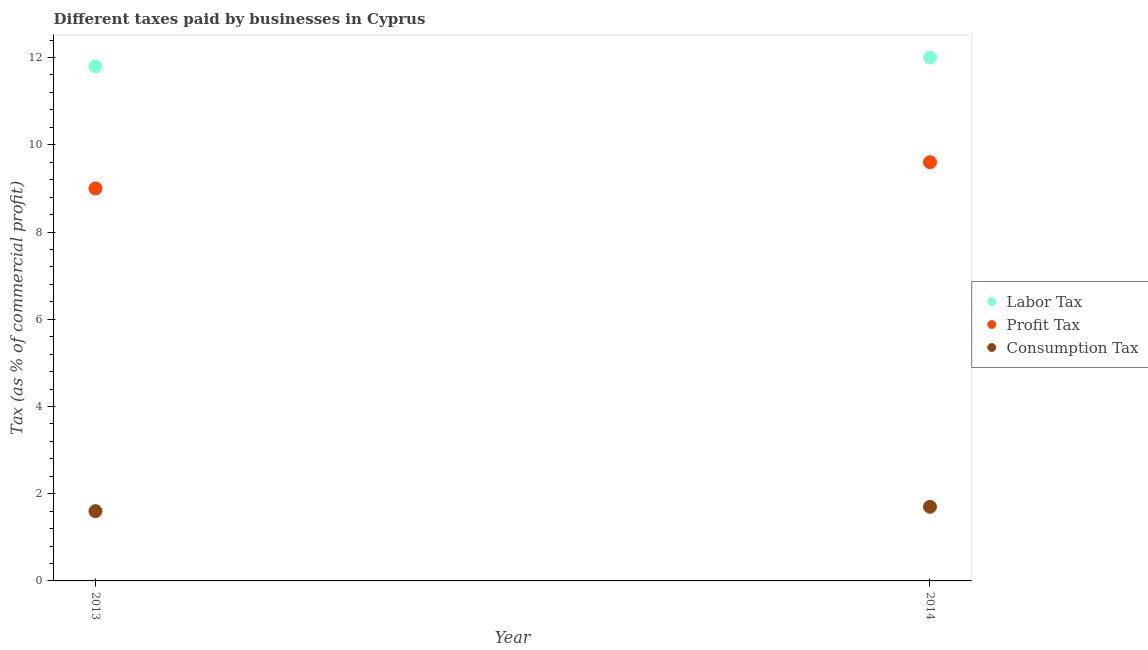Is the number of dotlines equal to the number of legend labels?
Make the answer very short. Yes. In which year was the percentage of profit tax maximum?
Make the answer very short. 2014. What is the total percentage of consumption tax in the graph?
Offer a very short reply. 3.3. What is the difference between the percentage of consumption tax in 2013 and that in 2014?
Provide a succinct answer. -0.1. What is the average percentage of consumption tax per year?
Ensure brevity in your answer.  1.65. In the year 2014, what is the difference between the percentage of consumption tax and percentage of profit tax?
Offer a terse response. -7.9. What is the ratio of the percentage of labor tax in 2013 to that in 2014?
Make the answer very short. 0.98. Is the percentage of labor tax in 2013 less than that in 2014?
Ensure brevity in your answer.  Yes. In how many years, is the percentage of profit tax greater than the average percentage of profit tax taken over all years?
Keep it short and to the point. 1. Is it the case that in every year, the sum of the percentage of labor tax and percentage of profit tax is greater than the percentage of consumption tax?
Provide a succinct answer. Yes. Is the percentage of labor tax strictly less than the percentage of profit tax over the years?
Offer a very short reply. No. What is the difference between two consecutive major ticks on the Y-axis?
Your answer should be very brief. 2. Are the values on the major ticks of Y-axis written in scientific E-notation?
Your answer should be compact. No. Where does the legend appear in the graph?
Your answer should be very brief. Center right. How are the legend labels stacked?
Give a very brief answer. Vertical. What is the title of the graph?
Make the answer very short. Different taxes paid by businesses in Cyprus. Does "Labor Tax" appear as one of the legend labels in the graph?
Provide a short and direct response. Yes. What is the label or title of the Y-axis?
Your answer should be compact. Tax (as % of commercial profit). What is the Tax (as % of commercial profit) of Labor Tax in 2013?
Provide a succinct answer. 11.8. What is the Tax (as % of commercial profit) of Profit Tax in 2013?
Provide a succinct answer. 9. What is the Tax (as % of commercial profit) in Consumption Tax in 2013?
Provide a succinct answer. 1.6. What is the Tax (as % of commercial profit) in Profit Tax in 2014?
Your response must be concise. 9.6. What is the Tax (as % of commercial profit) in Consumption Tax in 2014?
Provide a short and direct response. 1.7. Across all years, what is the maximum Tax (as % of commercial profit) of Labor Tax?
Make the answer very short. 12. Across all years, what is the maximum Tax (as % of commercial profit) of Profit Tax?
Your answer should be compact. 9.6. Across all years, what is the maximum Tax (as % of commercial profit) of Consumption Tax?
Your answer should be compact. 1.7. Across all years, what is the minimum Tax (as % of commercial profit) of Profit Tax?
Offer a terse response. 9. What is the total Tax (as % of commercial profit) of Labor Tax in the graph?
Keep it short and to the point. 23.8. What is the total Tax (as % of commercial profit) of Consumption Tax in the graph?
Provide a succinct answer. 3.3. What is the difference between the Tax (as % of commercial profit) in Profit Tax in 2013 and that in 2014?
Ensure brevity in your answer.  -0.6. What is the difference between the Tax (as % of commercial profit) of Labor Tax in 2013 and the Tax (as % of commercial profit) of Consumption Tax in 2014?
Give a very brief answer. 10.1. What is the difference between the Tax (as % of commercial profit) in Profit Tax in 2013 and the Tax (as % of commercial profit) in Consumption Tax in 2014?
Give a very brief answer. 7.3. What is the average Tax (as % of commercial profit) in Profit Tax per year?
Your answer should be compact. 9.3. What is the average Tax (as % of commercial profit) in Consumption Tax per year?
Your response must be concise. 1.65. In the year 2013, what is the difference between the Tax (as % of commercial profit) of Labor Tax and Tax (as % of commercial profit) of Consumption Tax?
Give a very brief answer. 10.2. In the year 2013, what is the difference between the Tax (as % of commercial profit) in Profit Tax and Tax (as % of commercial profit) in Consumption Tax?
Keep it short and to the point. 7.4. In the year 2014, what is the difference between the Tax (as % of commercial profit) of Labor Tax and Tax (as % of commercial profit) of Profit Tax?
Provide a short and direct response. 2.4. In the year 2014, what is the difference between the Tax (as % of commercial profit) in Profit Tax and Tax (as % of commercial profit) in Consumption Tax?
Offer a terse response. 7.9. What is the ratio of the Tax (as % of commercial profit) of Labor Tax in 2013 to that in 2014?
Provide a succinct answer. 0.98. What is the ratio of the Tax (as % of commercial profit) in Profit Tax in 2013 to that in 2014?
Your answer should be very brief. 0.94. What is the ratio of the Tax (as % of commercial profit) of Consumption Tax in 2013 to that in 2014?
Your answer should be compact. 0.94. What is the difference between the highest and the second highest Tax (as % of commercial profit) in Consumption Tax?
Provide a succinct answer. 0.1. What is the difference between the highest and the lowest Tax (as % of commercial profit) in Labor Tax?
Give a very brief answer. 0.2. What is the difference between the highest and the lowest Tax (as % of commercial profit) in Profit Tax?
Offer a very short reply. 0.6. What is the difference between the highest and the lowest Tax (as % of commercial profit) in Consumption Tax?
Your response must be concise. 0.1. 